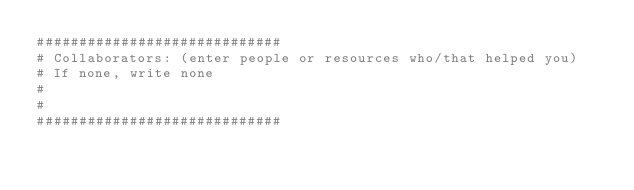<code> <loc_0><loc_0><loc_500><loc_500><_Python_>#############################
# Collaborators: (enter people or resources who/that helped you)
# If none, write none
#
#
#############################
</code> 